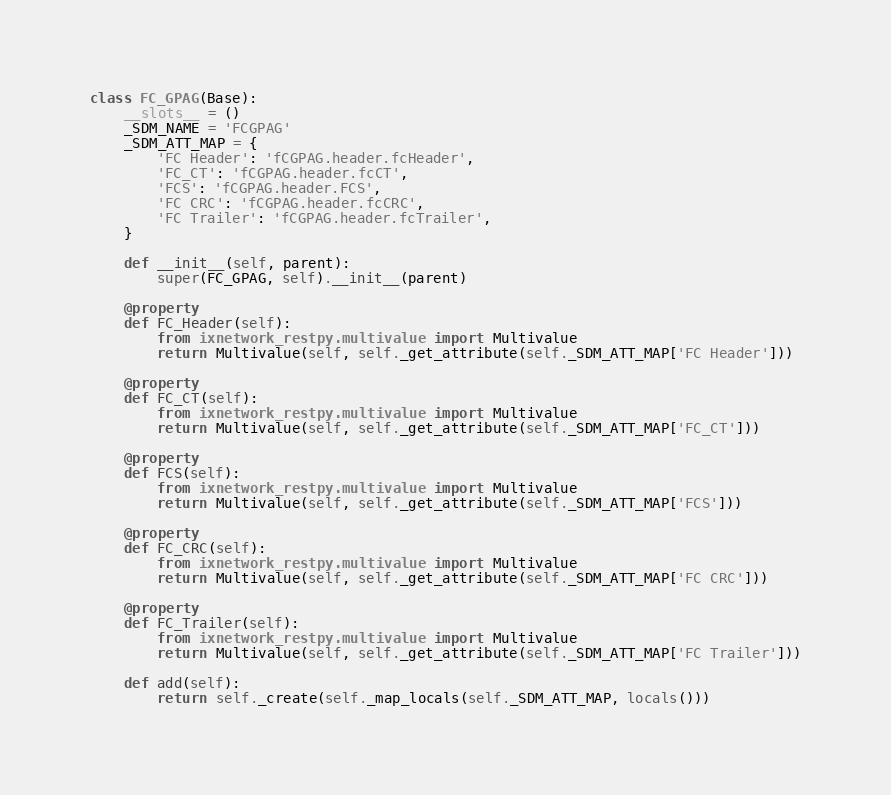<code> <loc_0><loc_0><loc_500><loc_500><_Python_>

class FC_GPAG(Base):
    __slots__ = ()
    _SDM_NAME = 'FCGPAG'
    _SDM_ATT_MAP = {
        'FC Header': 'fCGPAG.header.fcHeader',
        'FC_CT': 'fCGPAG.header.fcCT',
        'FCS': 'fCGPAG.header.FCS',
        'FC CRC': 'fCGPAG.header.fcCRC',
        'FC Trailer': 'fCGPAG.header.fcTrailer',
    }

    def __init__(self, parent):
        super(FC_GPAG, self).__init__(parent)

    @property
    def FC_Header(self):
        from ixnetwork_restpy.multivalue import Multivalue
        return Multivalue(self, self._get_attribute(self._SDM_ATT_MAP['FC Header']))

    @property
    def FC_CT(self):
        from ixnetwork_restpy.multivalue import Multivalue
        return Multivalue(self, self._get_attribute(self._SDM_ATT_MAP['FC_CT']))

    @property
    def FCS(self):
        from ixnetwork_restpy.multivalue import Multivalue
        return Multivalue(self, self._get_attribute(self._SDM_ATT_MAP['FCS']))

    @property
    def FC_CRC(self):
        from ixnetwork_restpy.multivalue import Multivalue
        return Multivalue(self, self._get_attribute(self._SDM_ATT_MAP['FC CRC']))

    @property
    def FC_Trailer(self):
        from ixnetwork_restpy.multivalue import Multivalue
        return Multivalue(self, self._get_attribute(self._SDM_ATT_MAP['FC Trailer']))

    def add(self):
        return self._create(self._map_locals(self._SDM_ATT_MAP, locals()))
</code> 